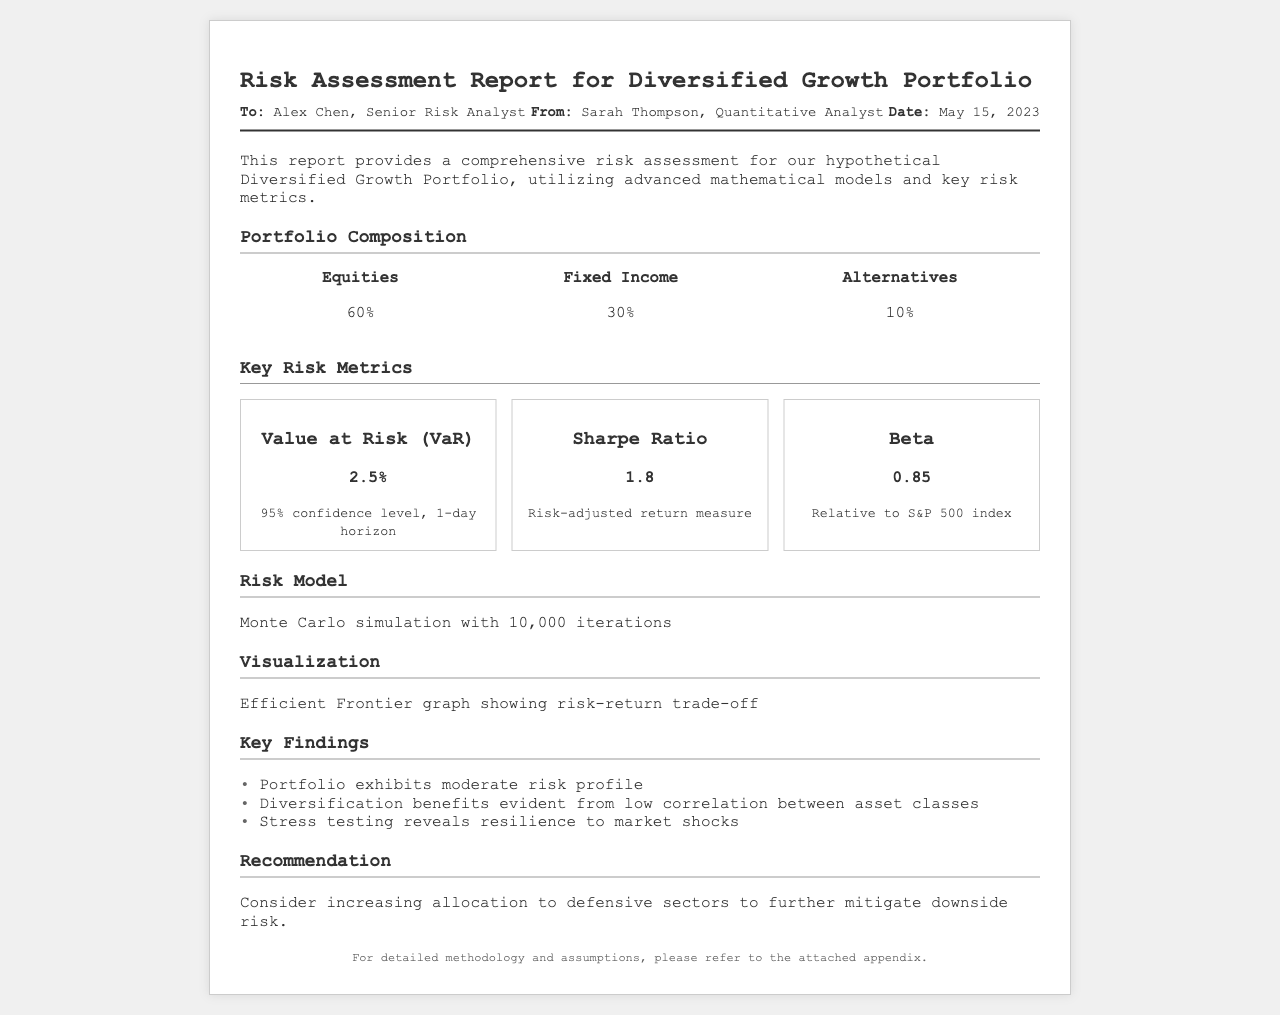What is the name of the portfolio? The portfolio is referred to as the "Diversified Growth Portfolio" in the document.
Answer: Diversified Growth Portfolio What percentage of the portfolio is allocated to Fixed Income? The document states that 30% of the portfolio is allocated to Fixed Income.
Answer: 30% What is the Value at Risk (VaR) for the portfolio? The VaR metric mentioned in the document is 2.5% at a 95% confidence level.
Answer: 2.5% What risk model was used for the assessment? The document indicates that a Monte Carlo simulation was used for the risk assessment.
Answer: Monte Carlo simulation What is the Sharpe Ratio of the portfolio? The document lists the Sharpe Ratio as 1.8 for the portfolio.
Answer: 1.8 What is the key finding regarding the portfolio's risk profile? According to the document, the portfolio exhibits a "moderate risk profile."
Answer: moderate risk profile Who authored the report? The report is authored by Sarah Thompson, a Quantitative Analyst as per the document.
Answer: Sarah Thompson What is recommended to mitigate downside risk? The recommendation is to "consider increasing allocation to defensive sectors."
Answer: increasing allocation to defensive sectors How many iterations were used in the Monte Carlo simulation? The document mentions that the simulation used 10,000 iterations.
Answer: 10,000 